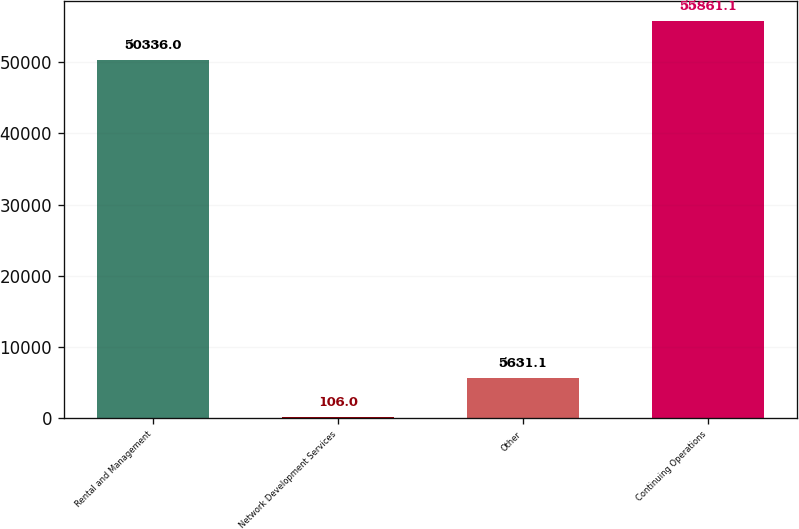Convert chart. <chart><loc_0><loc_0><loc_500><loc_500><bar_chart><fcel>Rental and Management<fcel>Network Development Services<fcel>Other<fcel>Continuing Operations<nl><fcel>50336<fcel>106<fcel>5631.1<fcel>55861.1<nl></chart> 